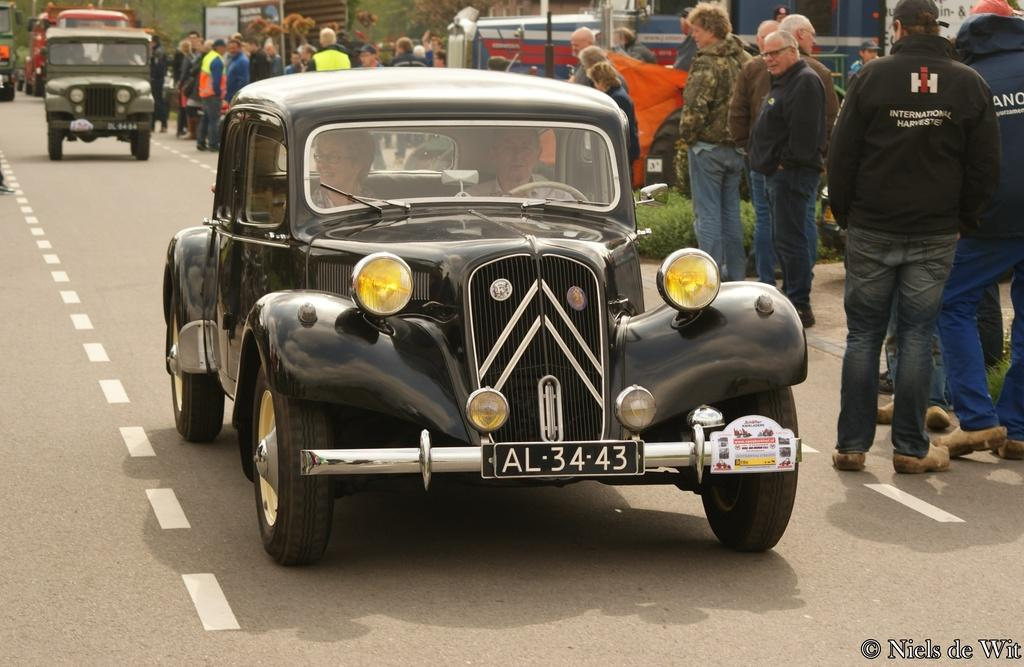What can be seen on the road in the image? There are several cars on the road. Are there any people present in the image? Yes, there are spectators on either side of the road. What type of instrument is the monkey playing in the image? There is no monkey or instrument present in the image. 